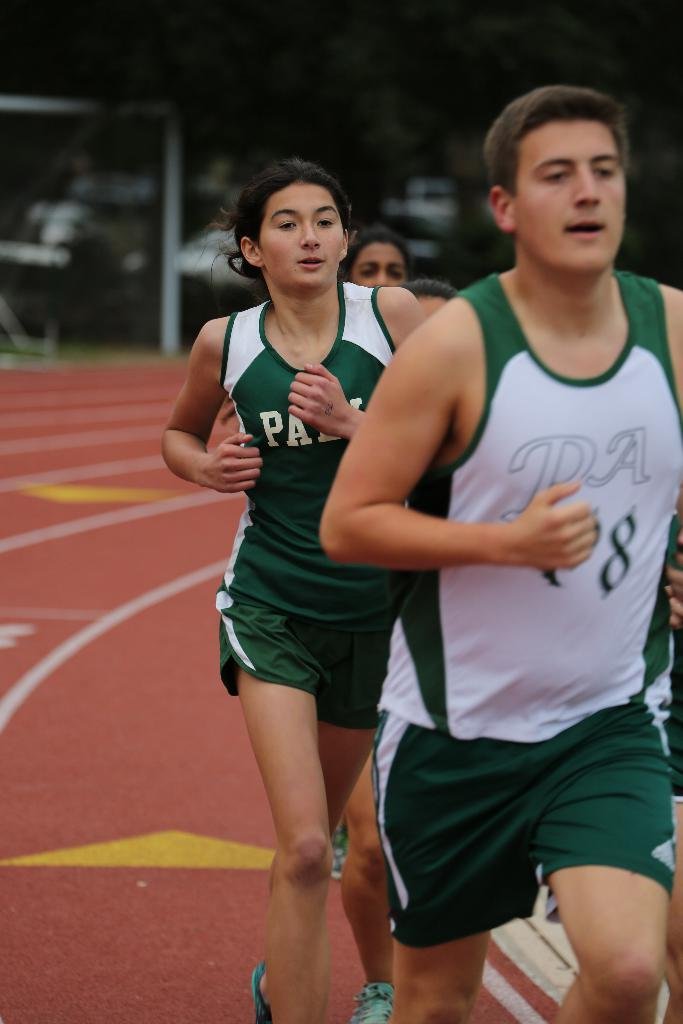Provide a one-sentence caption for the provided image. A person wearing a white and green shirt that has the number 8 runs on a track with other people. 